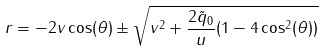<formula> <loc_0><loc_0><loc_500><loc_500>r = - 2 v \cos ( \theta ) \pm \sqrt { v ^ { 2 } + \frac { 2 \tilde { q } _ { 0 } } { u } ( 1 - 4 \cos ^ { 2 } ( \theta ) ) }</formula> 